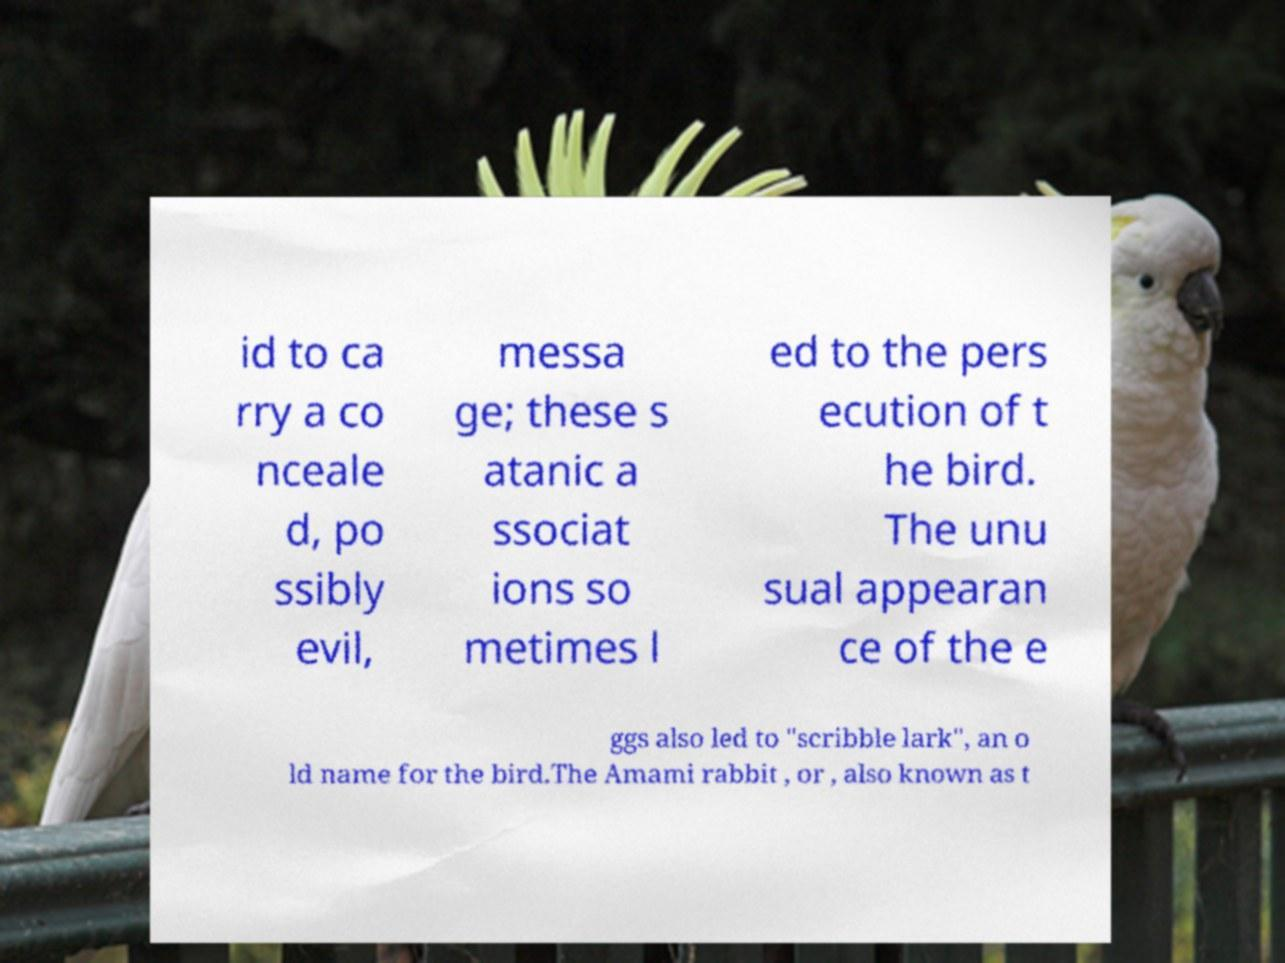Please read and relay the text visible in this image. What does it say? id to ca rry a co nceale d, po ssibly evil, messa ge; these s atanic a ssociat ions so metimes l ed to the pers ecution of t he bird. The unu sual appearan ce of the e ggs also led to "scribble lark", an o ld name for the bird.The Amami rabbit , or , also known as t 